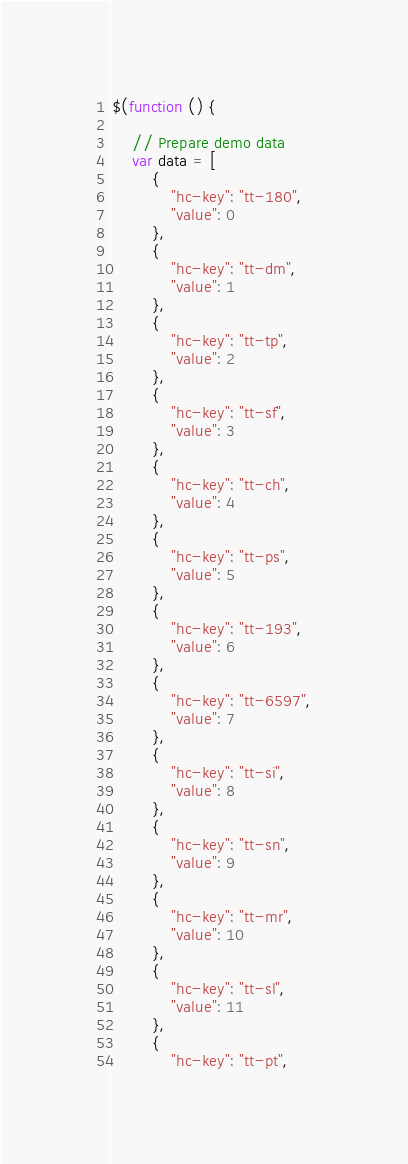Convert code to text. <code><loc_0><loc_0><loc_500><loc_500><_JavaScript_>$(function () {

    // Prepare demo data
    var data = [
        {
            "hc-key": "tt-180",
            "value": 0
        },
        {
            "hc-key": "tt-dm",
            "value": 1
        },
        {
            "hc-key": "tt-tp",
            "value": 2
        },
        {
            "hc-key": "tt-sf",
            "value": 3
        },
        {
            "hc-key": "tt-ch",
            "value": 4
        },
        {
            "hc-key": "tt-ps",
            "value": 5
        },
        {
            "hc-key": "tt-193",
            "value": 6
        },
        {
            "hc-key": "tt-6597",
            "value": 7
        },
        {
            "hc-key": "tt-si",
            "value": 8
        },
        {
            "hc-key": "tt-sn",
            "value": 9
        },
        {
            "hc-key": "tt-mr",
            "value": 10
        },
        {
            "hc-key": "tt-sl",
            "value": 11
        },
        {
            "hc-key": "tt-pt",</code> 